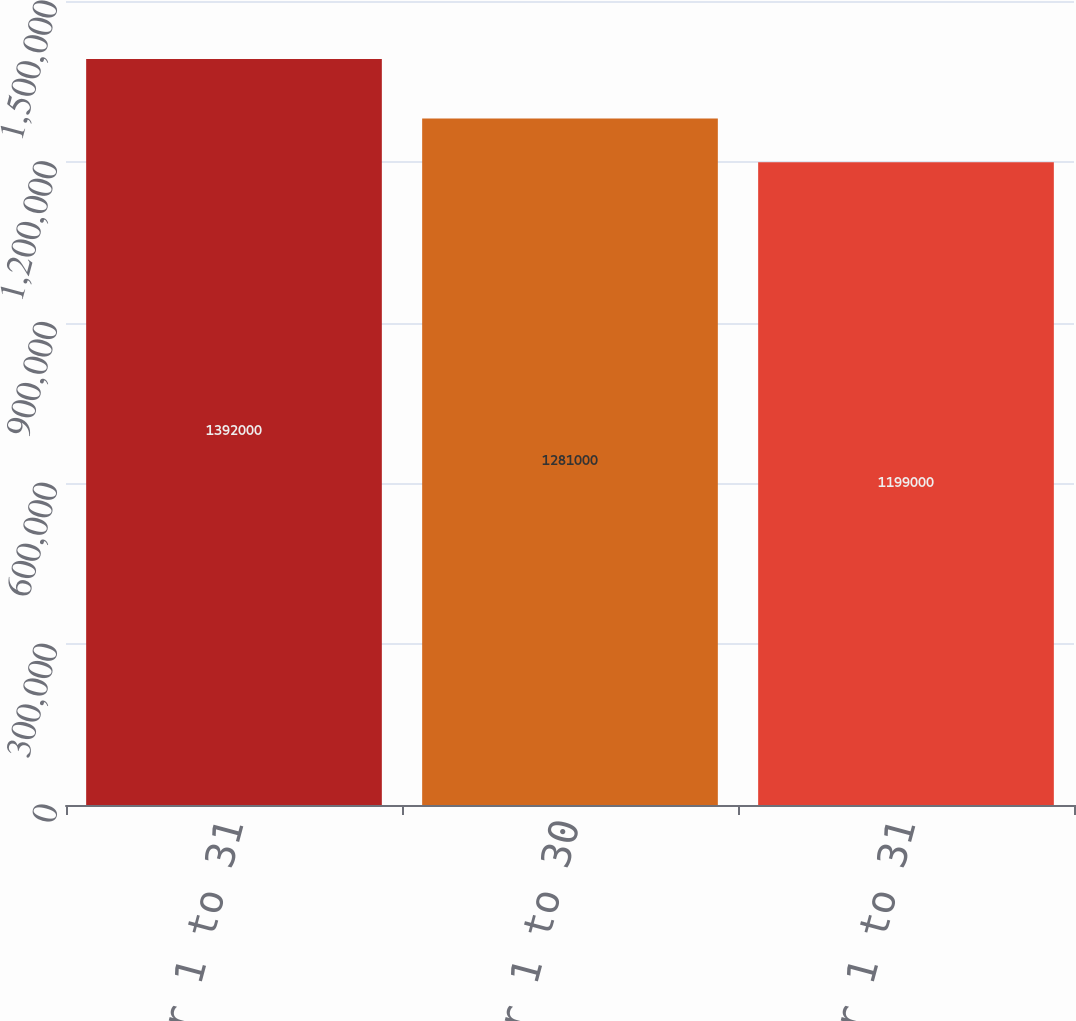<chart> <loc_0><loc_0><loc_500><loc_500><bar_chart><fcel>October 1 to 31<fcel>November 1 to 30<fcel>December 1 to 31<nl><fcel>1.392e+06<fcel>1.281e+06<fcel>1.199e+06<nl></chart> 